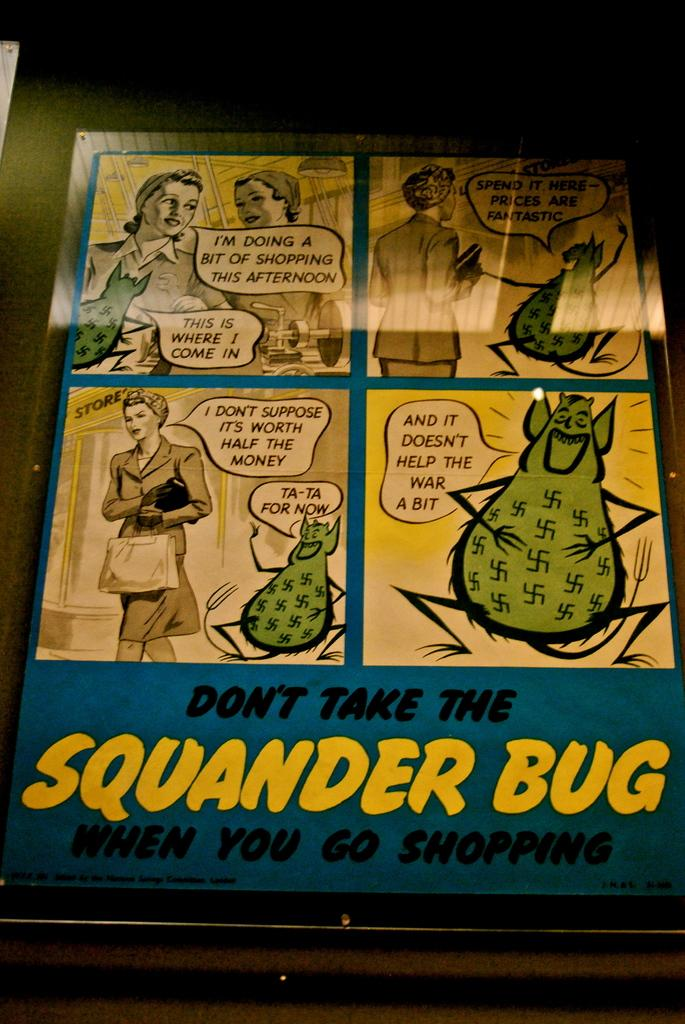<image>
Offer a succinct explanation of the picture presented. a poster that says 'don't take the squander bug when you go shopping' on it 